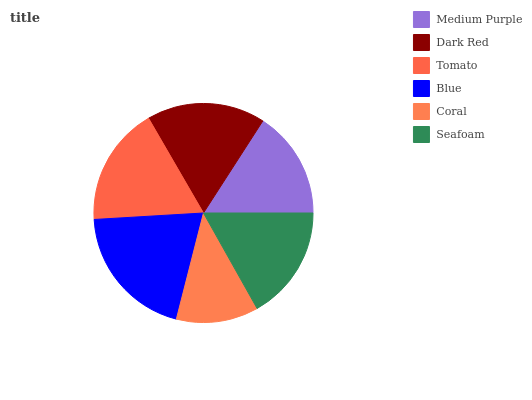Is Coral the minimum?
Answer yes or no. Yes. Is Blue the maximum?
Answer yes or no. Yes. Is Dark Red the minimum?
Answer yes or no. No. Is Dark Red the maximum?
Answer yes or no. No. Is Dark Red greater than Medium Purple?
Answer yes or no. Yes. Is Medium Purple less than Dark Red?
Answer yes or no. Yes. Is Medium Purple greater than Dark Red?
Answer yes or no. No. Is Dark Red less than Medium Purple?
Answer yes or no. No. Is Dark Red the high median?
Answer yes or no. Yes. Is Seafoam the low median?
Answer yes or no. Yes. Is Tomato the high median?
Answer yes or no. No. Is Tomato the low median?
Answer yes or no. No. 